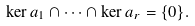Convert formula to latex. <formula><loc_0><loc_0><loc_500><loc_500>\ker a _ { 1 } \cap \cdots \cap \ker a _ { r } = \{ 0 \} .</formula> 